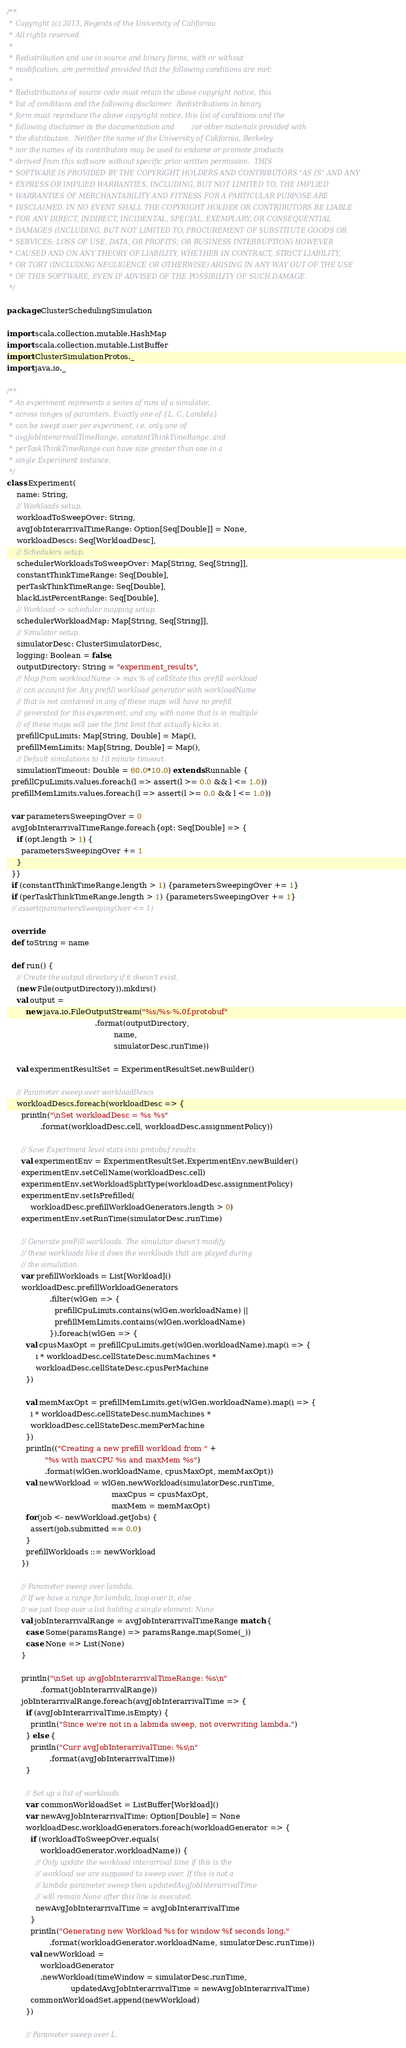<code> <loc_0><loc_0><loc_500><loc_500><_Scala_>/**
 * Copyright (c) 2013, Regents of the University of California
 * All rights reserved.
 *
 * Redistribution and use in source and binary forms, with or without
 * modification, are permitted provided that the following conditions are met:
 *
 * Redistributions of source code must retain the above copyright notice, this
 * list of conditions and the following disclaimer.  Redistributions in binary
 * form must reproduce the above copyright notice, this list of conditions and the
 * following disclaimer in the documentation and/or other materials provided with
 * the distribution.  Neither the name of the University of California, Berkeley
 * nor the names of its contributors may be used to endorse or promote products
 * derived from this software without specific prior written permission.  THIS
 * SOFTWARE IS PROVIDED BY THE COPYRIGHT HOLDERS AND CONTRIBUTORS "AS IS" AND ANY
 * EXPRESS OR IMPLIED WARRANTIES, INCLUDING, BUT NOT LIMITED TO, THE IMPLIED
 * WARRANTIES OF MERCHANTABILITY AND FITNESS FOR A PARTICULAR PURPOSE ARE
 * DISCLAIMED. IN NO EVENT SHALL THE COPYRIGHT HOLDER OR CONTRIBUTORS BE LIABLE
 * FOR ANY DIRECT, INDIRECT, INCIDENTAL, SPECIAL, EXEMPLARY, OR CONSEQUENTIAL
 * DAMAGES (INCLUDING, BUT NOT LIMITED TO, PROCUREMENT OF SUBSTITUTE GOODS OR
 * SERVICES; LOSS OF USE, DATA, OR PROFITS; OR BUSINESS INTERRUPTION) HOWEVER
 * CAUSED AND ON ANY THEORY OF LIABILITY, WHETHER IN CONTRACT, STRICT LIABILITY,
 * OR TORT (INCLUDING NEGLIGENCE OR OTHERWISE) ARISING IN ANY WAY OUT OF THE USE
 * OF THIS SOFTWARE, EVEN IF ADVISED OF THE POSSIBILITY OF SUCH DAMAGE.
 */

package ClusterSchedulingSimulation

import scala.collection.mutable.HashMap
import scala.collection.mutable.ListBuffer
import ClusterSimulationProtos._
import java.io._

/**
 * An experiment represents a series of runs of a simulator,
 * across ranges of paramters. Exactly one of {L, C, Lambda}
 * can be swept over per experiment, i.e. only one of
 * avgJobInterarrivalTimeRange, constantThinkTimeRange, and
 * perTaskThinkTimeRange can have size greater than one in a
 * single Experiment instance.
 */
class Experiment(
    name: String,
    // Workloads setup.
    workloadToSweepOver: String,
    avgJobInterarrivalTimeRange: Option[Seq[Double]] = None,
    workloadDescs: Seq[WorkloadDesc],
    // Schedulers setup.
    schedulerWorkloadsToSweepOver: Map[String, Seq[String]],
    constantThinkTimeRange: Seq[Double],
    perTaskThinkTimeRange: Seq[Double],
    blackListPercentRange: Seq[Double],
    // Workload -> scheduler mapping setup.
    schedulerWorkloadMap: Map[String, Seq[String]],
    // Simulator setup.
    simulatorDesc: ClusterSimulatorDesc,
    logging: Boolean = false,
    outputDirectory: String = "experiment_results",
    // Map from workloadName -> max % of cellState this prefill workload
    // can account for. Any prefill workload generator with workloadName
    // that is not contained in any of these maps will have no prefill
    // generated for this experiment, and any with name that is in multiple
    // of these maps will use the first limit that actually kicks in.
    prefillCpuLimits: Map[String, Double] = Map(),
    prefillMemLimits: Map[String, Double] = Map(),
    // Default simulations to 10 minute timeout.
    simulationTimeout: Double = 60.0*10.0) extends Runnable {
  prefillCpuLimits.values.foreach(l => assert(l >= 0.0 && l <= 1.0))
  prefillMemLimits.values.foreach(l => assert(l >= 0.0 && l <= 1.0))

  var parametersSweepingOver = 0
  avgJobInterarrivalTimeRange.foreach{opt: Seq[Double] => {
    if (opt.length > 1) {
      parametersSweepingOver += 1
    }
  }}
  if (constantThinkTimeRange.length > 1) {parametersSweepingOver += 1}
  if (perTaskThinkTimeRange.length > 1) {parametersSweepingOver += 1}
  // assert(parametersSweepingOver <= 1)

  override
  def toString = name

  def run() {
    // Create the output directory if it doesn't exist.
    (new File(outputDirectory)).mkdirs()
    val output =
        new java.io.FileOutputStream("%s/%s-%.0f.protobuf"
                                     .format(outputDirectory,
                                             name,
                                             simulatorDesc.runTime))

    val experimentResultSet = ExperimentResultSet.newBuilder()

    // Parameter sweep over workloadDescs
    workloadDescs.foreach(workloadDesc => {
      println("\nSet workloadDesc = %s %s"
              .format(workloadDesc.cell, workloadDesc.assignmentPolicy))

      // Save Experiment level stats into protobuf results.
      val experimentEnv = ExperimentResultSet.ExperimentEnv.newBuilder()
      experimentEnv.setCellName(workloadDesc.cell)
      experimentEnv.setWorkloadSplitType(workloadDesc.assignmentPolicy)
      experimentEnv.setIsPrefilled(
          workloadDesc.prefillWorkloadGenerators.length > 0)
      experimentEnv.setRunTime(simulatorDesc.runTime)

      // Generate preFill workloads. The simulator doesn't modify
      // these workloads like it does the workloads that are played during
      // the simulation.
      var prefillWorkloads = List[Workload]()
      workloadDesc.prefillWorkloadGenerators
                  .filter(wlGen => {
                    prefillCpuLimits.contains(wlGen.workloadName) ||
                    prefillMemLimits.contains(wlGen.workloadName)
                  }).foreach(wlGen => {
        val cpusMaxOpt = prefillCpuLimits.get(wlGen.workloadName).map(i => {
            i * workloadDesc.cellStateDesc.numMachines *
            workloadDesc.cellStateDesc.cpusPerMachine
        })
                      
        val memMaxOpt = prefillMemLimits.get(wlGen.workloadName).map(i => {
          i * workloadDesc.cellStateDesc.numMachines *
          workloadDesc.cellStateDesc.memPerMachine
        })
        println(("Creating a new prefill workload from " +
                "%s with maxCPU %s and maxMem %s")
                .format(wlGen.workloadName, cpusMaxOpt, memMaxOpt))
        val newWorkload = wlGen.newWorkload(simulatorDesc.runTime,
                                            maxCpus = cpusMaxOpt,
                                            maxMem = memMaxOpt)
        for(job <- newWorkload.getJobs) {
          assert(job.submitted == 0.0)
        }
        prefillWorkloads ::= newWorkload
      })

      // Parameter sweep over lambda.
      // If we have a range for lambda, loop over it, else
      // we just loop over a list holding a single element: None 
      val jobInterarrivalRange = avgJobInterarrivalTimeRange match {
        case Some(paramsRange) => paramsRange.map(Some(_))
        case None => List(None)
      }

      println("\nSet up avgJobInterarrivalTimeRange: %s\n"
              .format(jobInterarrivalRange))
      jobInterarrivalRange.foreach(avgJobInterarrivalTime => {
        if (avgJobInterarrivalTime.isEmpty) {
          println("Since we're not in a labmda sweep, not overwriting lambda.")
        } else {
          println("Curr avgJobInterarrivalTime: %s\n"
                  .format(avgJobInterarrivalTime))
        }

        // Set up a list of workloads
        var commonWorkloadSet = ListBuffer[Workload]()
        var newAvgJobInterarrivalTime: Option[Double] = None
        workloadDesc.workloadGenerators.foreach(workloadGenerator => {
          if (workloadToSweepOver.equals(
              workloadGenerator.workloadName)) {
            // Only update the workload interarrival time if this is the
            // workload we are supposed to sweep over. If this is not a
            // lambda parameter sweep then updatedAvgJobInterarrivalTime
            // will remain None after this line is executed.
            newAvgJobInterarrivalTime = avgJobInterarrivalTime          
          }
          println("Generating new Workload %s for window %f seconds long."
                  .format(workloadGenerator.workloadName, simulatorDesc.runTime))
          val newWorkload =
              workloadGenerator
              .newWorkload(timeWindow = simulatorDesc.runTime,
                           updatedAvgJobInterarrivalTime = newAvgJobInterarrivalTime)
          commonWorkloadSet.append(newWorkload)
        })

        // Parameter sweep over L.</code> 